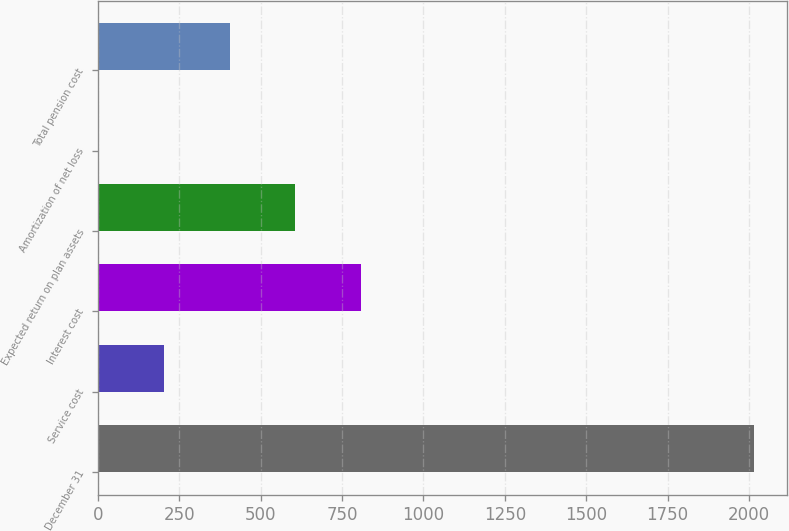Convert chart to OTSL. <chart><loc_0><loc_0><loc_500><loc_500><bar_chart><fcel>December 31<fcel>Service cost<fcel>Interest cost<fcel>Expected return on plan assets<fcel>Amortization of net loss<fcel>Total pension cost<nl><fcel>2016<fcel>203.4<fcel>807.6<fcel>606.2<fcel>2<fcel>404.8<nl></chart> 